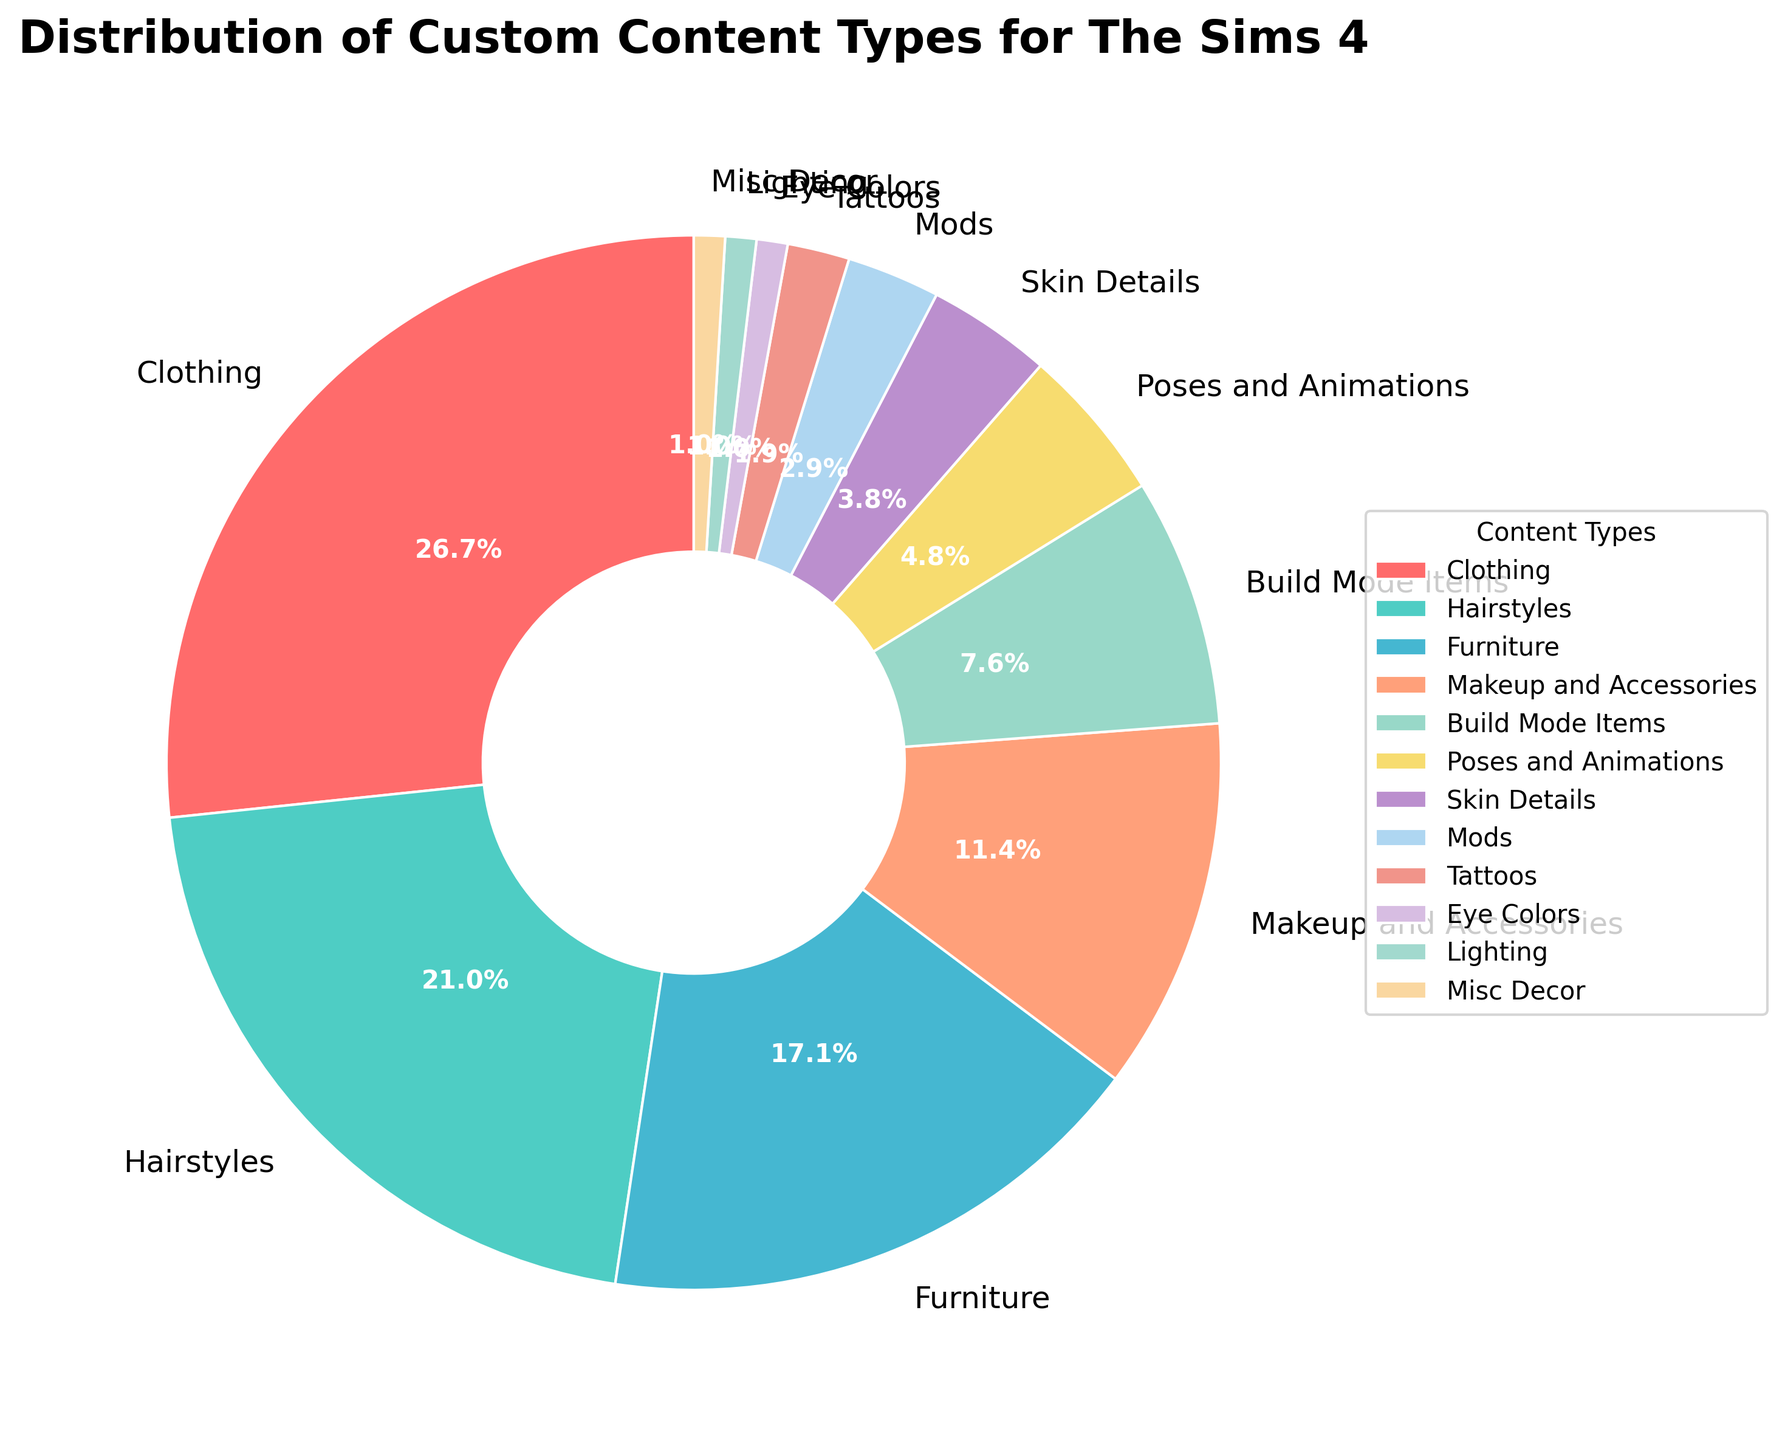Which custom content type has the highest percentage? The figure shows that Clothing has the highest percentage among custom content types.
Answer: Clothing How many custom content types have a percentage greater than 10%? When examining the figure, the custom content types with percentages greater than 10% are Clothing (28%), Hairstyles (22%), Furniture (18%), and Makeup and Accessories (12%). There are 4 such types.
Answer: 4 What is the combined percentage of Poses and Animations, Skin Details, and Mods? Adding the percentages of Poses and Animations (5%), Skin Details (4%), and Mods (3%), we get 5% + 4% + 3% = 12%.
Answer: 12% Which custom content type has the smallest percentage and what is its value? The figure shows that the content types with the smallest percentages are Eye Colors, Lighting, and Misc Decor, each with a percentage of 1%.
Answer: Eye Colors, Lighting, Misc Decor: 1% What is the difference in percentage between Clothing and Furniture? The figure indicates Clothing at 28% and Furniture at 18%, so the difference is 28% - 18% = 10%.
Answer: 10% Rank the custom content types with percentages between 10% and 20% in descending order. The relevant content types are Furniture and Makeup and Accessories, with percentages of 18% and 12%, respectively. The descending order is Furniture (18%) followed by Makeup and Accessories (12%).
Answer: Furniture > Makeup and Accessories Compare the combined percentage of Build Mode Items and Tattoos to that of Hairstyles. Which is greater? Build Mode Items have 8%, and Tattoos have 2%, summing to 10%. Hairstyles alone have 22%, which is greater than 10%.
Answer: Hairstyles By how much does the combined percentage of Misc Decor, Lighting, and Eye Colors exceed the percentage of Tattoos? Misc Decor, Lighting, and Eye Colors each have 1%, so combined they are 1% + 1% + 1% = 3%. Tattoos have 2%, so they exceed by 3% - 2% = 1%.
Answer: 1% What proportion of the custom content types have less than 5% representation? The content types with less than 5% are Skin Details (4%), Mods (3%), Tattoos (2%), Eye Colors (1%), Lighting (1%), and Misc Decor (1%), which totals 6 out of 12 types. The proportion is 6/12 = 1/2.
Answer: 1/2 What is the percentage difference between the most and least represented custom content types? Clothing is the most represented with 28%, and Eye Colors, Lighting, and Misc Decor are the least represented with 1%. The difference is 28% - 1% = 27%.
Answer: 27% 